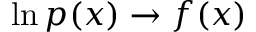<formula> <loc_0><loc_0><loc_500><loc_500>\ln { p ( x ) } \rightarrow f ( x )</formula> 